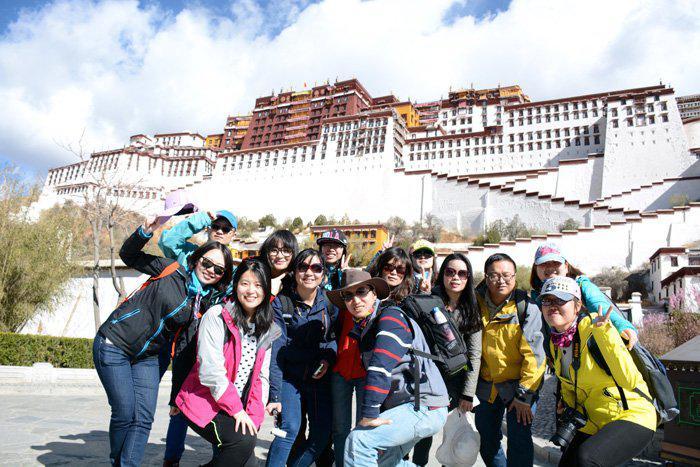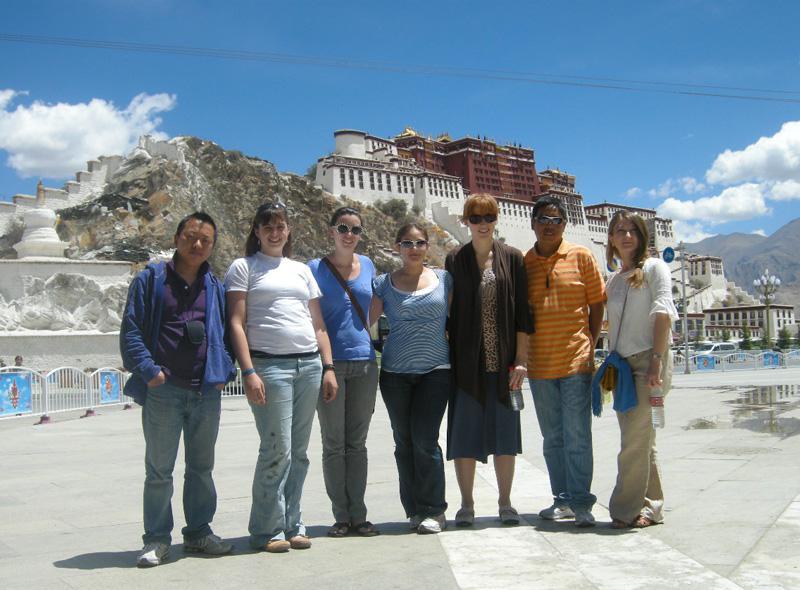The first image is the image on the left, the second image is the image on the right. Examine the images to the left and right. Is the description "In exactly one image a group of people are posing in front of a structure." accurate? Answer yes or no. No. The first image is the image on the left, the second image is the image on the right. For the images shown, is this caption "In at least one image there is a group standing in front of a three story white stari wall that is below four rows of window." true? Answer yes or no. Yes. 